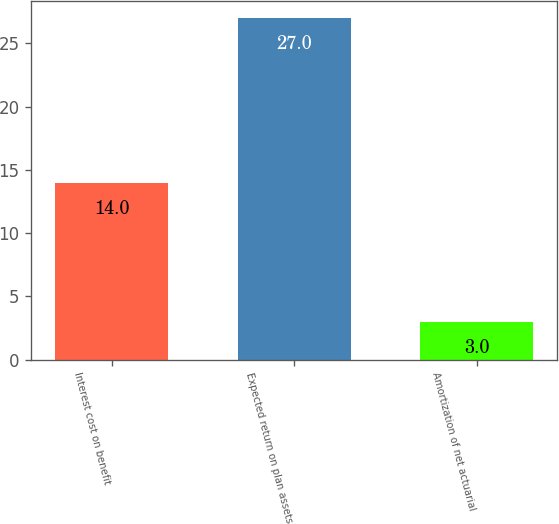<chart> <loc_0><loc_0><loc_500><loc_500><bar_chart><fcel>Interest cost on benefit<fcel>Expected return on plan assets<fcel>Amortization of net actuarial<nl><fcel>14<fcel>27<fcel>3<nl></chart> 